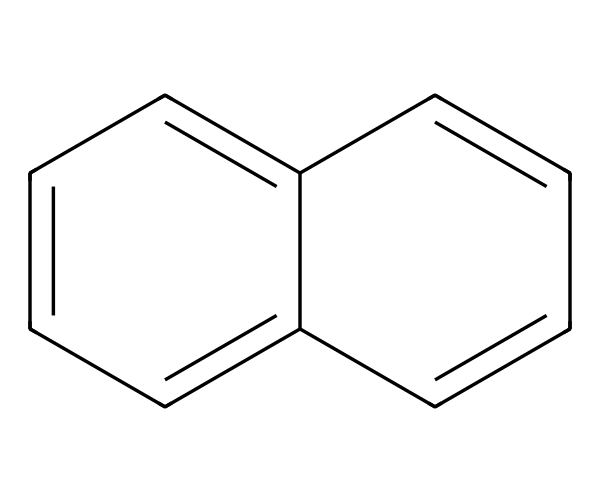What is the molecular formula of naphthalene? The molecular formula can be determined by counting the number of carbon and hydrogen atoms in the structure. There are ten carbon atoms and eight hydrogen atoms seen in the chemical structure, so the molecular formula is C10H8.
Answer: C10H8 How many rings are present in naphthalene? The structure of naphthalene shows two interconnected benzene rings, indicating that it is a bicyclic compound with two rings.
Answer: 2 What type of hybridization is present in naphthalene? Each carbon atom in naphthalene is part of a planar ring structure and is bonded to three other atoms. This implies that the carbon atoms are sp2 hybridized due to the presence of one double bond with adjacent carbons.
Answer: sp2 What property of naphthalene makes it a solid at room temperature? The structure of naphthalene has strong pi-pi stacking interactions due to aromaticity, and the relatively high molecular weight leads to stronger intermolecular forces (van der Waals forces), which makes it solid at room temperature.
Answer: solid Why is naphthalene classified as an aromatic compound? Naphthalene meets the criteria for aromaticity, including having a planar and cyclic structure, a continuous overlap of p-orbitals, and following Huckel's rule, which requires 4n + 2 π electrons where n is a non-negative integer. Naphthalene has 6 π electrons, thus it's aromatic.
Answer: aromatic What is the main use of naphthalene in everyday products? Naphthalene is commonly used in mothballs and some air fresheners due to its distinct odor and ability to repel pests, serving as a practical application of its chemical properties.
Answer: air fresheners 